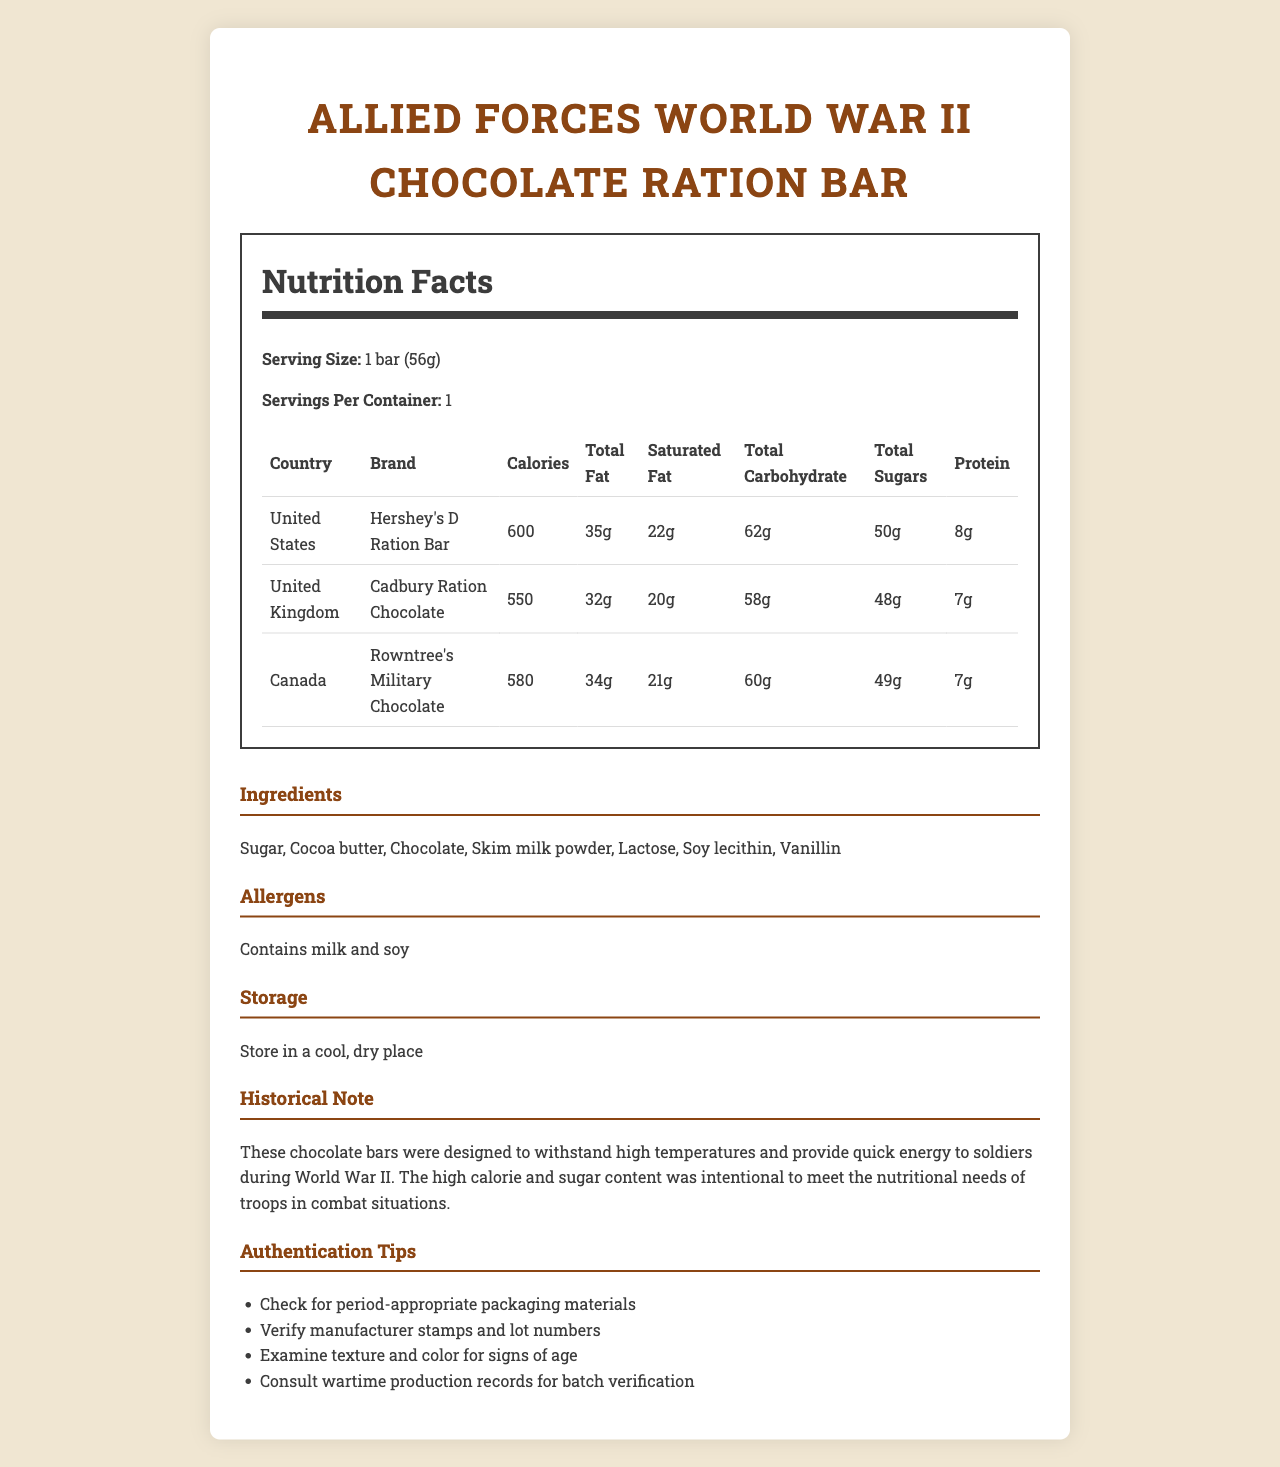what is the serving size of the chocolate bar? The serving size is clearly stated in the document under the "Serving Size" section.
Answer: 1 bar (56g) which country’s chocolate bar contains the highest total sugars? A. United States B. United Kingdom C. Canada The total sugars for each country are listed: United States (50g), United Kingdom (48g), and Canada (49g). The United States chocolate bar contains the highest total sugars.
Answer: A. United States does the document include any allergens? The document states under the "Allergens" section that the chocolate bars contain milk and soy.
Answer: Yes which bar has the lowest sodium content? The sodium content for each country is listed: United States (50g), United Kingdom (45g), and Canada (48g). The United Kingdom bar has the lowest sodium content.
Answer: United Kingdom summarize the main idea of the document. The document contains a comprehensive comparison of World War II chocolate bars from different Allied nations, detailing their nutritional content, ingredients, and other related information for historical and appraising purposes.
Answer: The document provides detailed nutrition facts for World War II chocolate bars from the United States, United Kingdom, and Canada, alongside ingredients, allergens, storage instructions, a historical note, and authentication tips. does the chocolate bar need to be refrigerated for storage? The storage instructions clearly state "Store in a cool, dry place," which does not require refrigeration.
Answer: No which bar has the highest calorie content? A. United States B. United Kingdom C. Canada The calorie content listed is as follows: United States (600), United Kingdom (550), and Canada (580). The United States bar has the highest calorie content.
Answer: A. United States what ingredient is common in all the chocolate bars? Sugar is listed as the first ingredient in the "Ingredients" section for all the chocolate bars.
Answer: Sugar what is the total fat content of the Canadian chocolate bar? The total fat content for Rowntree's Military Chocolate from Canada is specified as 34g in the nutrition table.
Answer: 34g can you determine the serving size of the chocolate bars from the visual information? The document states the serving size as "1 bar (56g)" in the nutrition label.
Answer: Yes how should the chocolate bars be stored? The document provides storage instructions in the "Storage" section.
Answer: Store in a cool, dry place which chocolate bar has the highest protein content? The protein content for each country is listed: United States (8g), United Kingdom (7g), and Canada (7g). The United States bar has the highest protein content.
Answer: United States which ingredient provides emulsification in the chocolate bars? Soy lecithin is commonly used as an emulsifier and is listed in the ingredients.
Answer: Soy lecithin what time period do these chocolate bars originate from? The historical note clearly mentions that the chocolate bars were designed for use during World War II.
Answer: World War II which chocolate bar has the lowest saturated fat content? A. United States B. United Kingdom C. Canada The saturated fat content listed is: United States (22g), United Kingdom (20g), and Canada (21g). The United Kingdom bar has the lowest saturated fat content.
Answer: B. United Kingdom what is the purpose of the high calorie and sugar content in these chocolate bars? The historical note explains that the high calorie and sugar content was intentional to meet the nutritional needs of troops in combat situations.
Answer: To provide quick energy to soldiers during combat situations is there any information about wartime production records in the document? The authentication tips suggest consulting wartime production records for batch verification.
Answer: Yes 